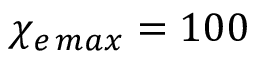Convert formula to latex. <formula><loc_0><loc_0><loc_500><loc_500>\chi _ { e \, \max } = 1 0 0</formula> 